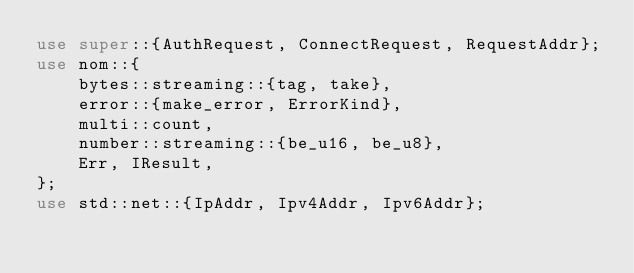Convert code to text. <code><loc_0><loc_0><loc_500><loc_500><_Rust_>use super::{AuthRequest, ConnectRequest, RequestAddr};
use nom::{
    bytes::streaming::{tag, take},
    error::{make_error, ErrorKind},
    multi::count,
    number::streaming::{be_u16, be_u8},
    Err, IResult,
};
use std::net::{IpAddr, Ipv4Addr, Ipv6Addr};
</code> 